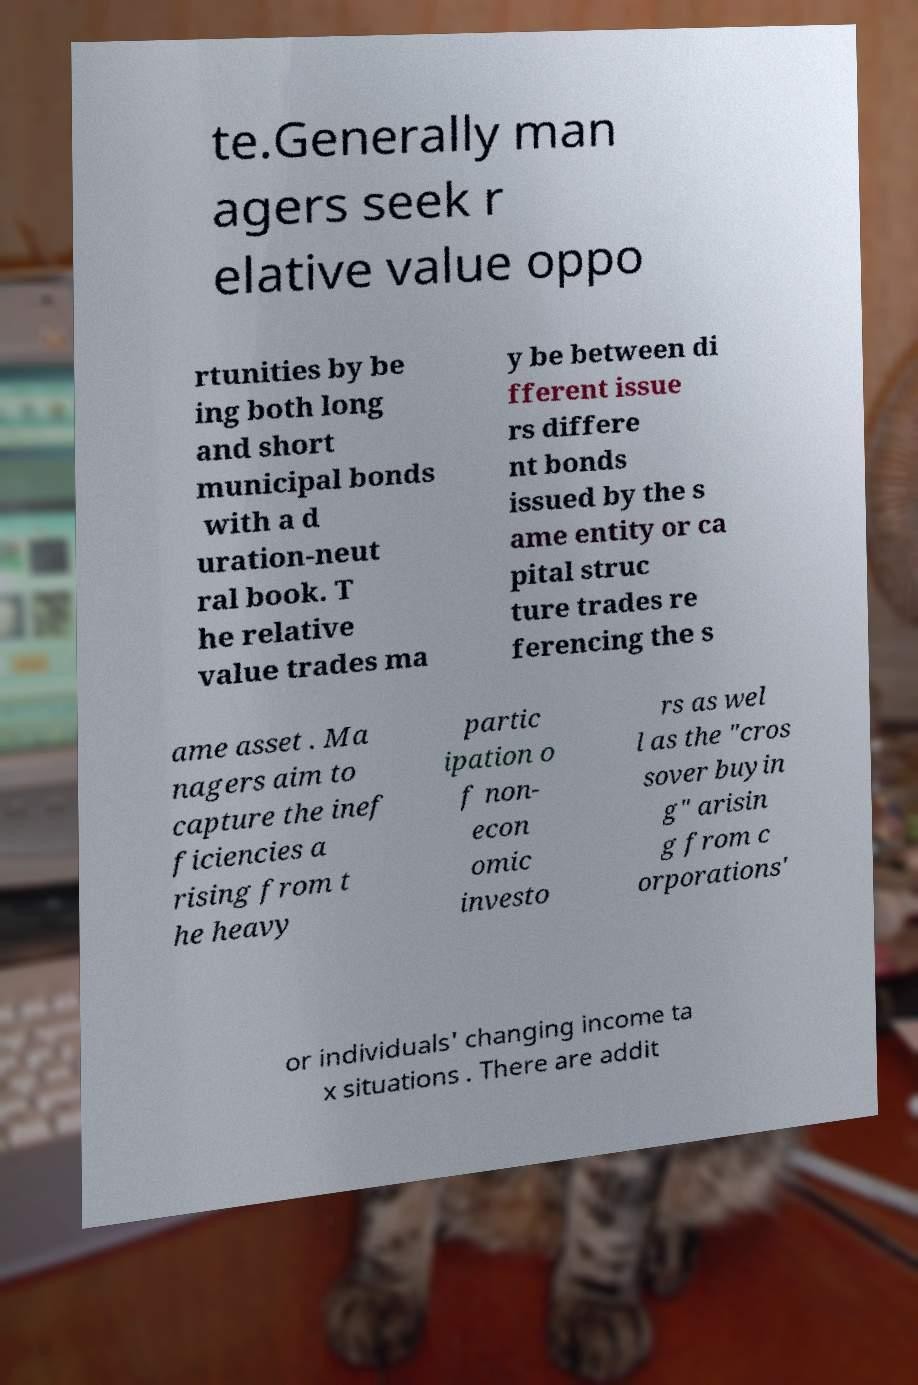I need the written content from this picture converted into text. Can you do that? te.Generally man agers seek r elative value oppo rtunities by be ing both long and short municipal bonds with a d uration-neut ral book. T he relative value trades ma y be between di fferent issue rs differe nt bonds issued by the s ame entity or ca pital struc ture trades re ferencing the s ame asset . Ma nagers aim to capture the inef ficiencies a rising from t he heavy partic ipation o f non- econ omic investo rs as wel l as the "cros sover buyin g" arisin g from c orporations' or individuals' changing income ta x situations . There are addit 